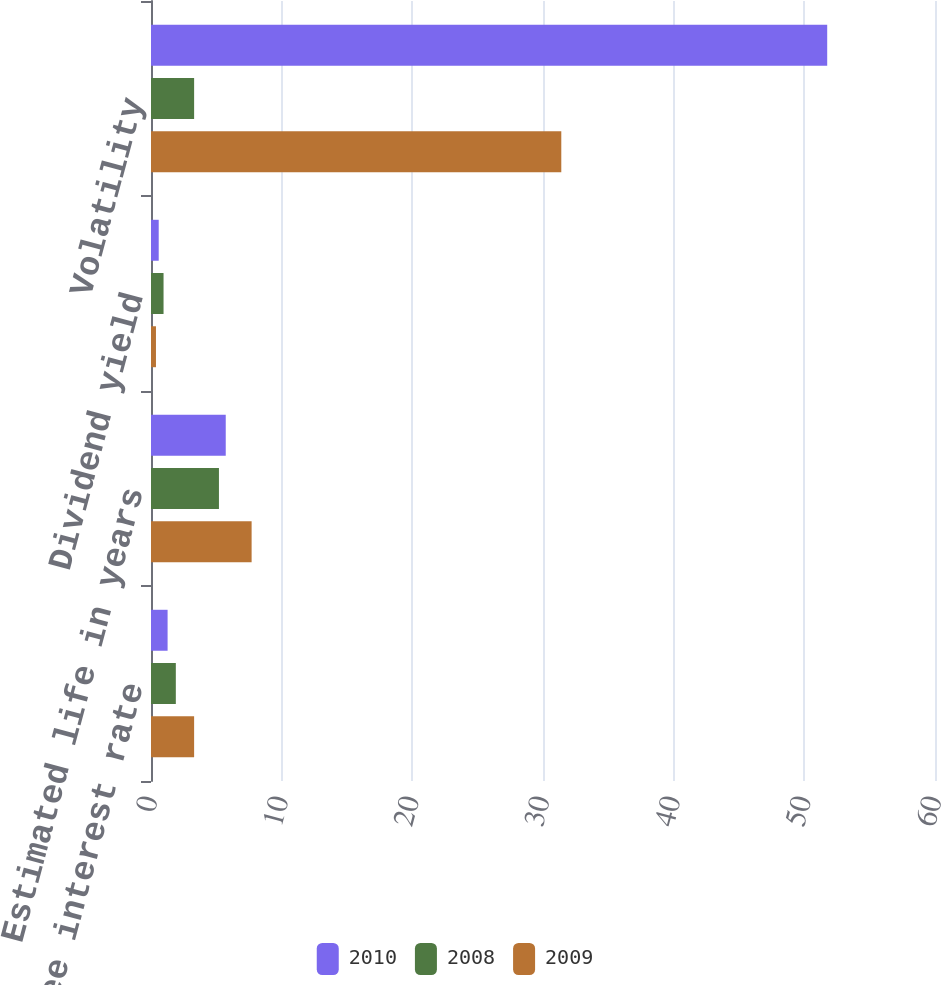<chart> <loc_0><loc_0><loc_500><loc_500><stacked_bar_chart><ecel><fcel>Risk-free interest rate<fcel>Estimated life in years<fcel>Dividend yield<fcel>Volatility<nl><fcel>2010<fcel>1.27<fcel>5.72<fcel>0.59<fcel>51.75<nl><fcel>2008<fcel>1.9<fcel>5.2<fcel>0.96<fcel>3.3<nl><fcel>2009<fcel>3.3<fcel>7.7<fcel>0.38<fcel>31.4<nl></chart> 